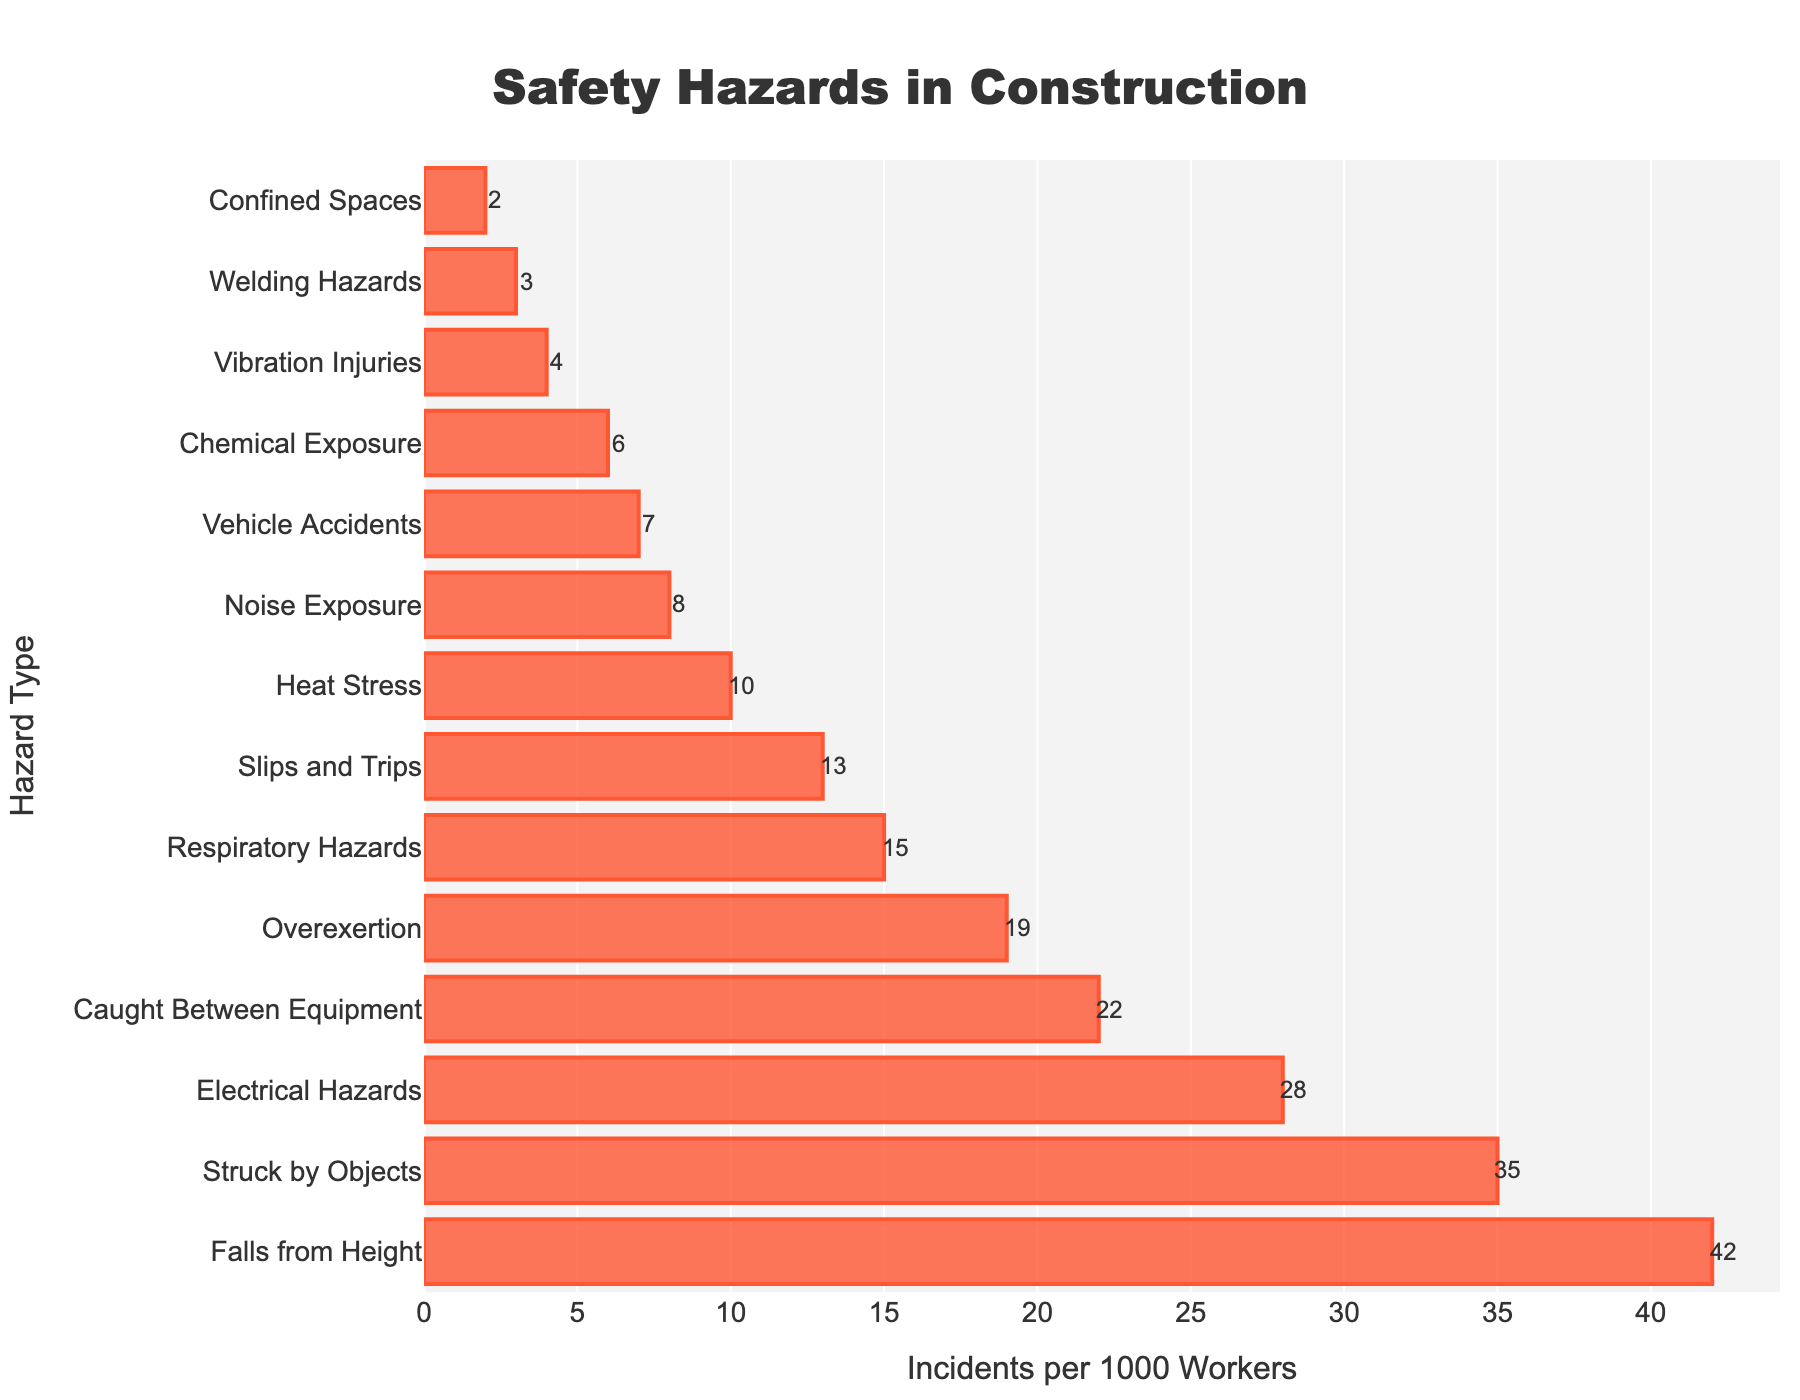What's the most common type of hazard? The most common type of hazard is identified by the bar with the highest value. In this case, 'Falls from Height' is the highest with 42 incidents per 1000 workers.
Answer: Falls from Height Which hazard type has the least incidents? The least common hazard type is identified by the bar with the smallest value. In this case, 'Confined Spaces' has the smallest value with 2 incidents per 1000 workers.
Answer: Confined Spaces What's the total number of incidents for 'Electrical Hazards' and 'Chemical Exposure'? sum the incidents for 'Electrical Hazards' (28) and 'Chemical Exposure' (6). 28 + 6 equals 34.
Answer: 34 How many more incidents do 'Falls from Height' have compared to 'Overexertion'? To find the difference, subtract the incidents in 'Overexertion' (19) from 'Falls from Height' (42). 42 - 19 equals 23.
Answer: 23 Compare 'Vehicle Accidents' and 'Noise Exposure', which one is less common? 'Vehicle Accidents' have 7 incidents, and 'Noise Exposure' has 8 incidents. Since 7 is less than 8, 'Vehicle Accidents' are less common.
Answer: Vehicle Accidents Are there more incidents of 'Struck by Objects' or 'Respiratory Hazards'? 'Struck by Objects' have 35 incidents, while 'Respiratory Hazards' have 15 incidents. Since 35 is greater than 15, 'Struck by Objects' have more incidents.
Answer: Struck by Objects What's the sum of incidents for the three least common hazards? The three least common hazards are 'Welding Hazards' (3), 'Confined Spaces' (2), and 'Vibration Injuries' (4). Sum these values: 3 + 2 + 4 equals 9.
Answer: 9 How do 'Heat Stress' and 'Respiratory Hazards' compare visually in the chart? To compare visually, observe the bar lengths. 'Respiratory Hazards' with 15 incidents have a longer bar compared to 'Heat Stress' with 10 incidents.
Answer: Respiratory Hazards have a longer bar What are the top three hazards in terms of incidents? The top three hazards can be identified by the bars with the highest values. They are 'Falls from Height' (42), 'Struck by Objects' (35), and 'Electrical Hazards' (28).
Answer: Falls from Height, Struck by Objects, Electrical Hazards What's the difference between the incidents of 'Slips and Trips' and 'Caught Between Equipment'? Subtract the incidents in 'Slips and Trips' (13) from 'Caught Between Equipment' (22). 22 - 13 equals 9.
Answer: 9 